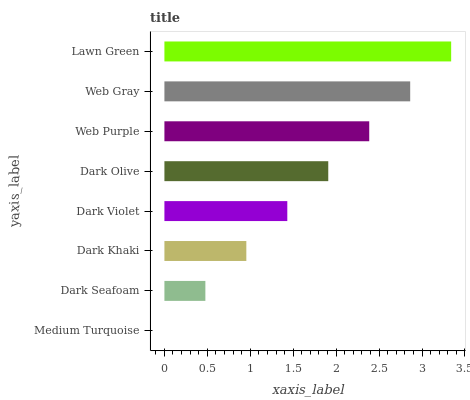Is Medium Turquoise the minimum?
Answer yes or no. Yes. Is Lawn Green the maximum?
Answer yes or no. Yes. Is Dark Seafoam the minimum?
Answer yes or no. No. Is Dark Seafoam the maximum?
Answer yes or no. No. Is Dark Seafoam greater than Medium Turquoise?
Answer yes or no. Yes. Is Medium Turquoise less than Dark Seafoam?
Answer yes or no. Yes. Is Medium Turquoise greater than Dark Seafoam?
Answer yes or no. No. Is Dark Seafoam less than Medium Turquoise?
Answer yes or no. No. Is Dark Olive the high median?
Answer yes or no. Yes. Is Dark Violet the low median?
Answer yes or no. Yes. Is Medium Turquoise the high median?
Answer yes or no. No. Is Medium Turquoise the low median?
Answer yes or no. No. 